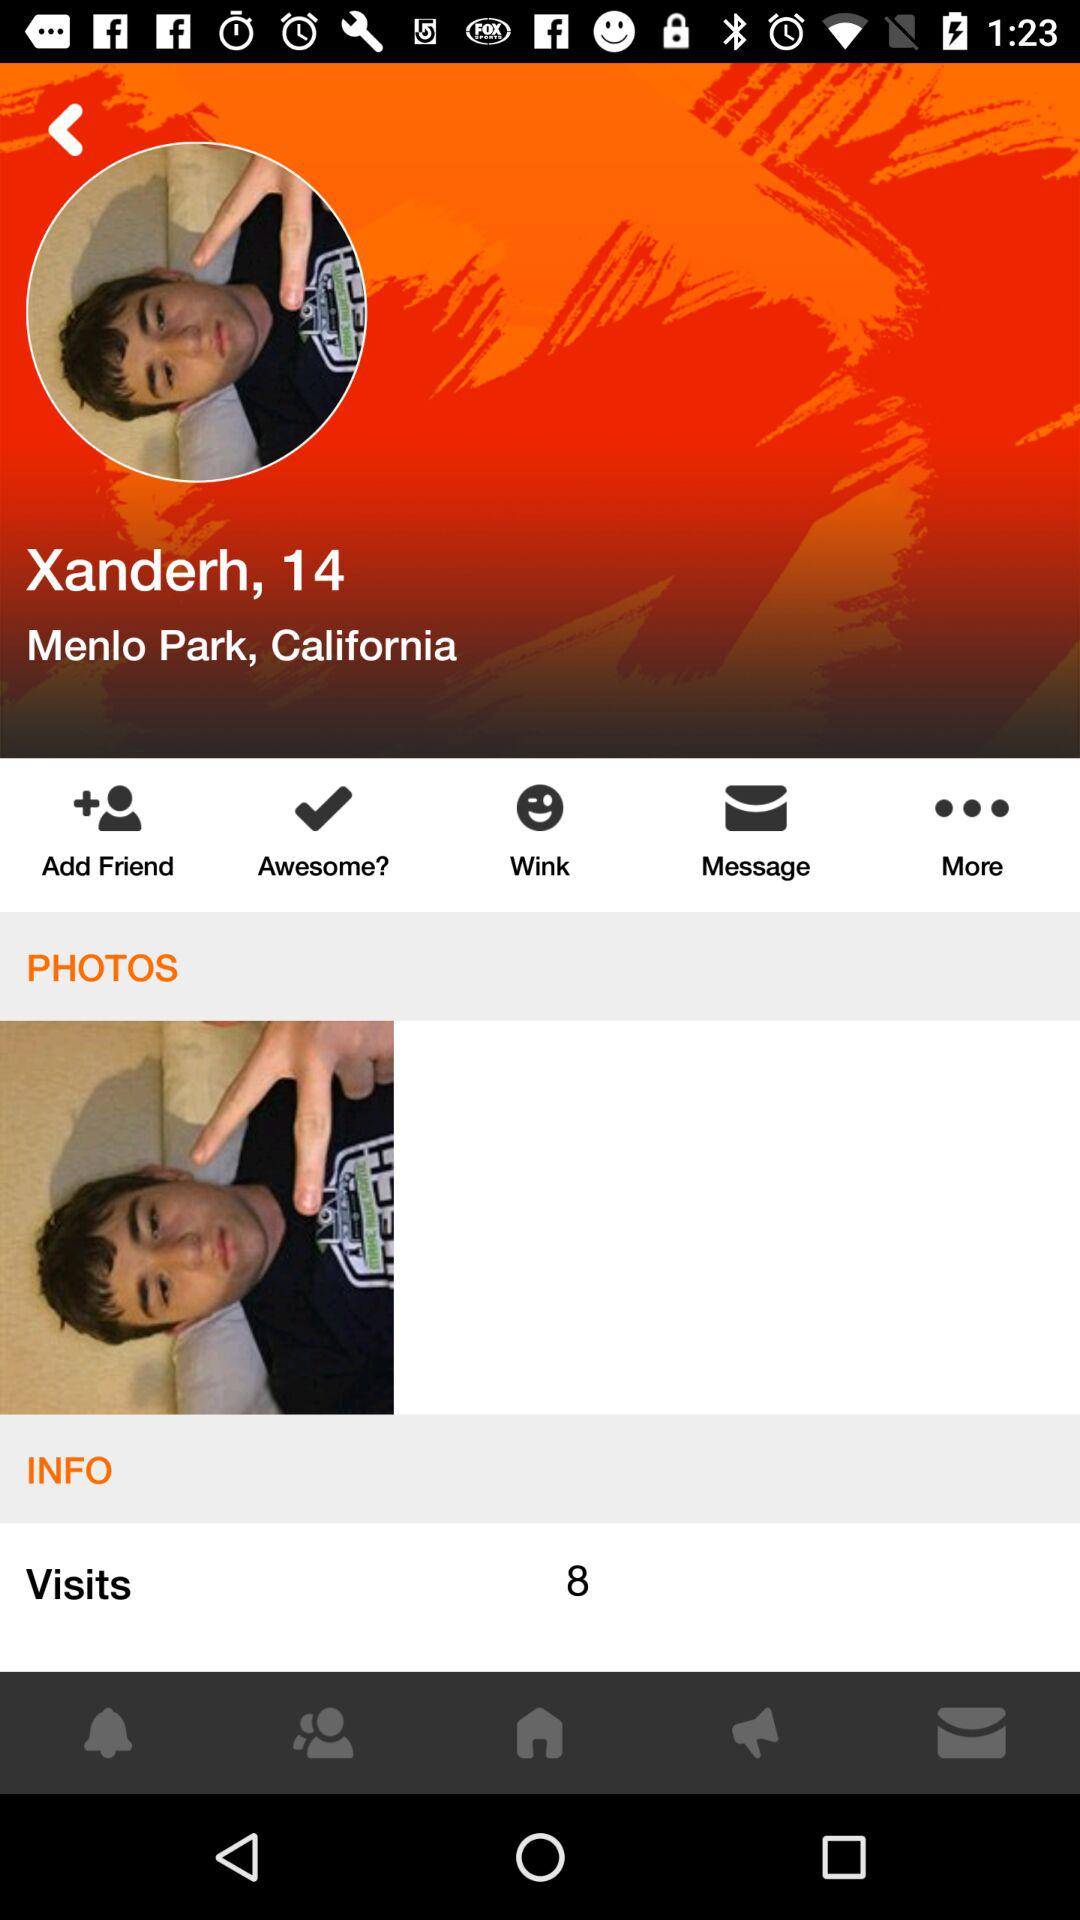How many visits in total are there on the profile? There are 8 visits on the profile. 